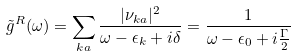Convert formula to latex. <formula><loc_0><loc_0><loc_500><loc_500>\tilde { g } ^ { R } ( \omega ) = \sum _ { k a } \frac { | \nu _ { k a } | ^ { 2 } } { \omega - { \epsilon } _ { k } + i \delta } = \frac { 1 } { \omega - { \epsilon } _ { 0 } + i \frac { \Gamma } { 2 } }</formula> 